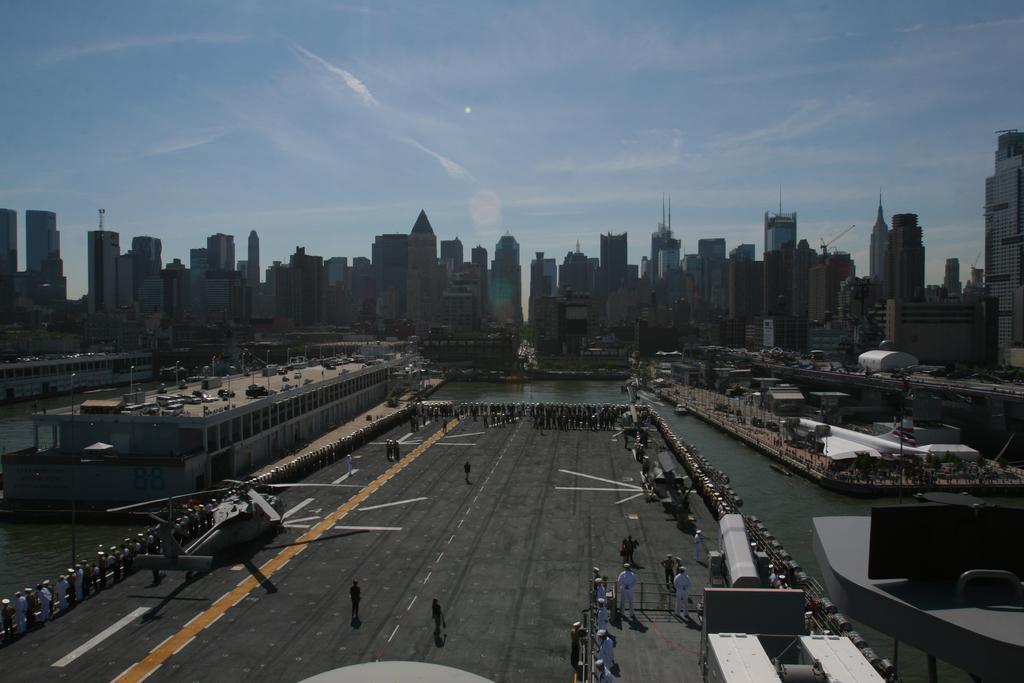Can you describe this image briefly? In the center of the image there is a runway. There is helicopter. There are people. In the background of the image there are buildings. There is water. At the top of the image there is sky. 